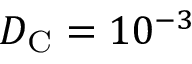<formula> <loc_0><loc_0><loc_500><loc_500>D _ { C } = 1 0 ^ { - 3 }</formula> 